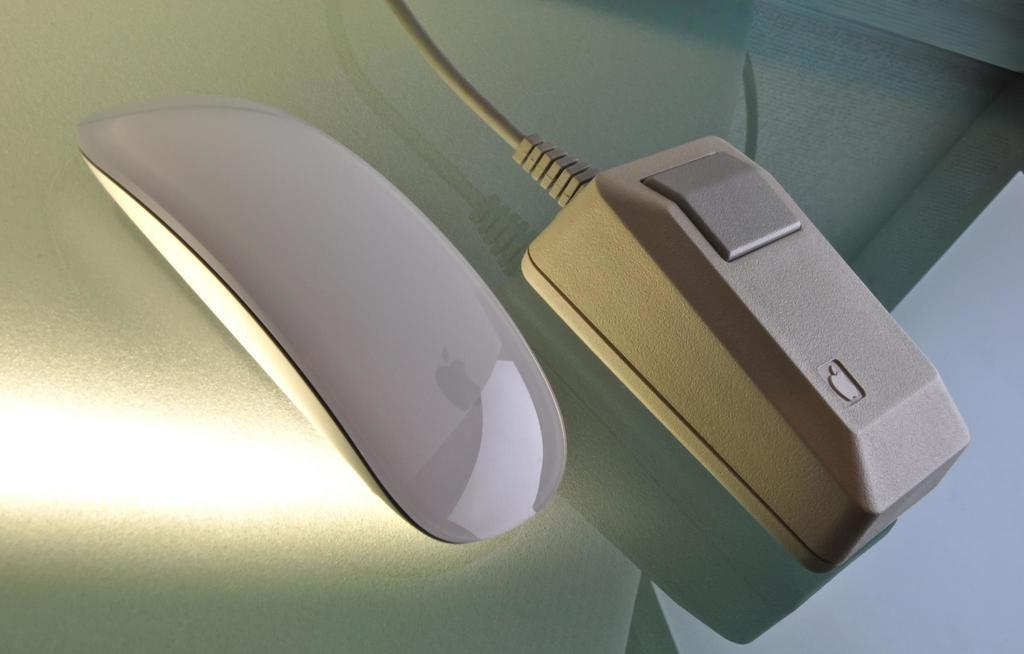What type of objects are present in the image? There are electronic gadgets in the image. Where are the electronic gadgets located? The electronic gadgets are placed on a glass surface. What type of grain can be seen growing on the faces of the electronic gadgets in the image? There is no grain or faces present on the electronic gadgets in the image. 